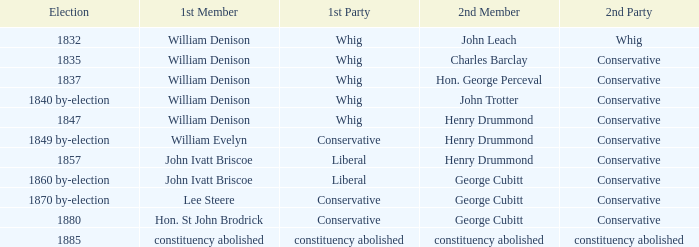In the 1835 election, which party has william denison as their first member? Conservative. 